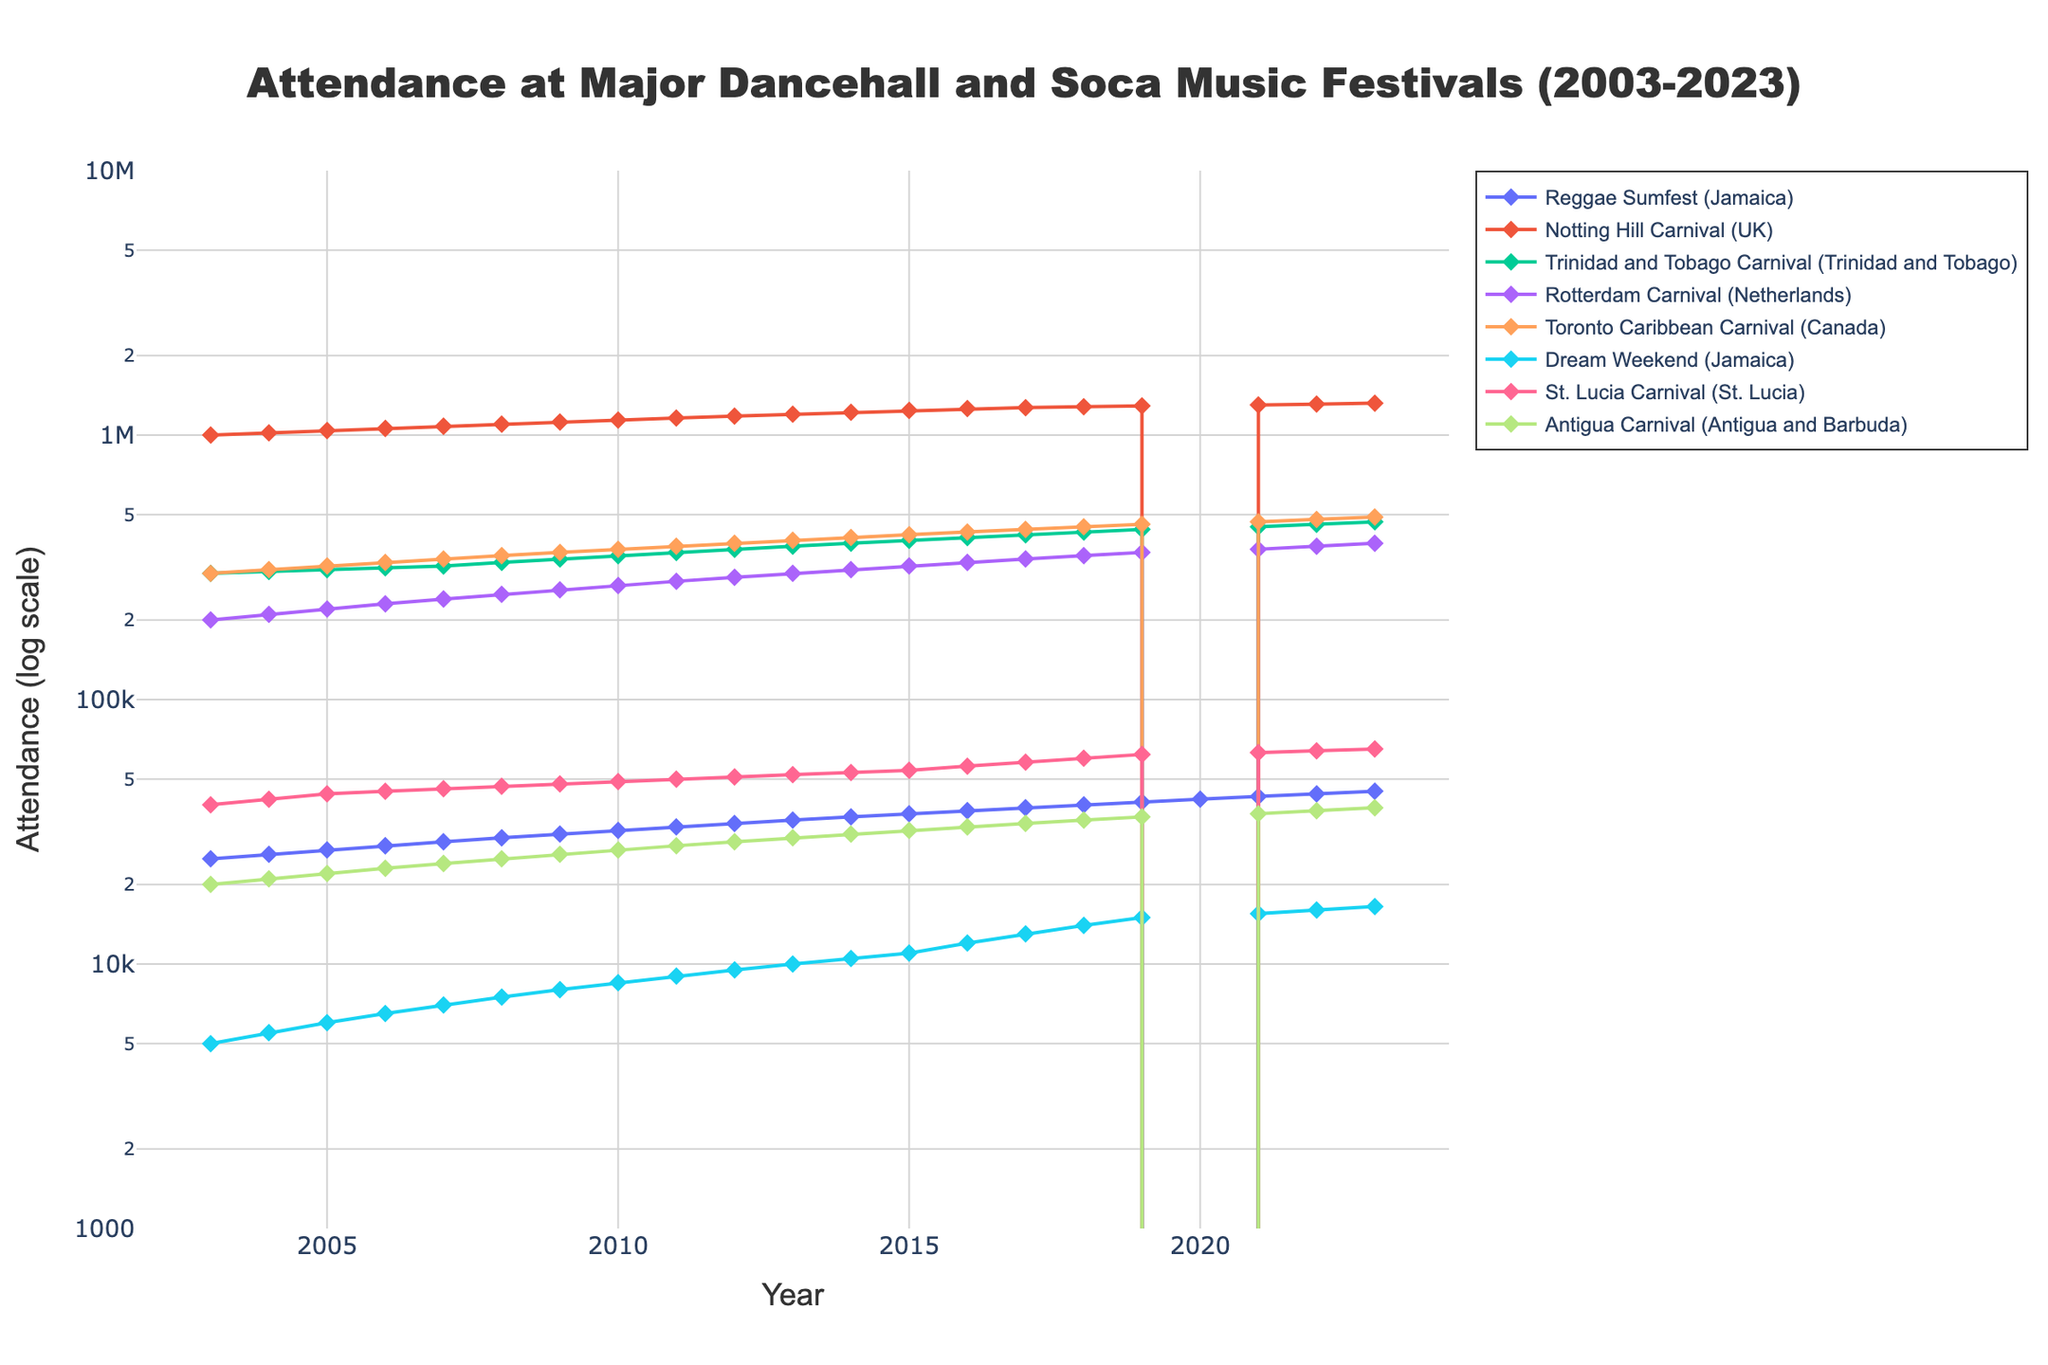What is the title of the figure? The title is located at the top center of the figure and is typically in a larger font size. In this case, the title mentions the type of data being plotted and the timeframe.
Answer: Attendance at Major Dancehall and Soca Music Festivals (2003-2023) Which festival had the highest attendance in 2023? To find this, locate the year 2023 on the x-axis and compare the y-values of different festivals. The highest y-value represents the festival with the highest attendance.
Answer: Notting Hill Carnival (UK) What trend can be observed for the Dream Weekend festival's attendance from 2015 to 2023? Track the line representing Dream Weekend from the year 2015 to 2023 on the x-axis. Look for whether the line is moving upwards, downwards, or remains flat.
Answer: Increasing How many festivals had zero attendance in 2020? Locate the year 2020 on the x-axis and count the number of lines that drop to the bottom of the plot, indicating zero attendance.
Answer: 6 By how much did the attendance of Reggae Sumfest (Jamaica) increase from 2003 to 2023? Find the values for Reggae Sumfest in 2003 and 2023 on the y-axis. Subtract the 2003 value from the 2023 value to get the increase.
Answer: 20,000 Which festival shows the most significant drop in attendance in 2020 compared to 2019? Compare the lines between the years 2019 and 2020. Identify the line that has the steepest drop.
Answer: Notting Hill Carnival (UK) and others since they all dropped to zero What is the average attendance of Toronto Caribbean Carnival over the decade from 2013 to 2023? Locate the data points for Toronto Caribbean Carnival between 2013 and 2023 on the y-axis. Sum these values and divide by the number of years (10).
Answer: 445,000 Between the Antigua Carnival and St. Lucia Carnival, which had a higher attendance in 2011? Locate the year 2011 on the x-axis and find the y-values for Antigua Carnival and St. Lucia Carnival. Compare the y-values to see which is higher.
Answer: St. Lucia Carnival Is there a general upward or downward trend in attendance for the Trinidad and Tobago Carnival? Follow the line representing Trinidad and Tobago Carnival from the start (2003) to the end (2023) noting the general direction of the line.
Answer: Upward Which festival had a more consistent increase in attendance over the 20 years: Rotterdam Carnival or Reggae Sumfest (Jamaica)? Analyze the lines for both festivals over the 20 years. A more consistent increase will show a steadier, less fluctuating rising line.
Answer: Reggae Sumfest (Jamaica) 